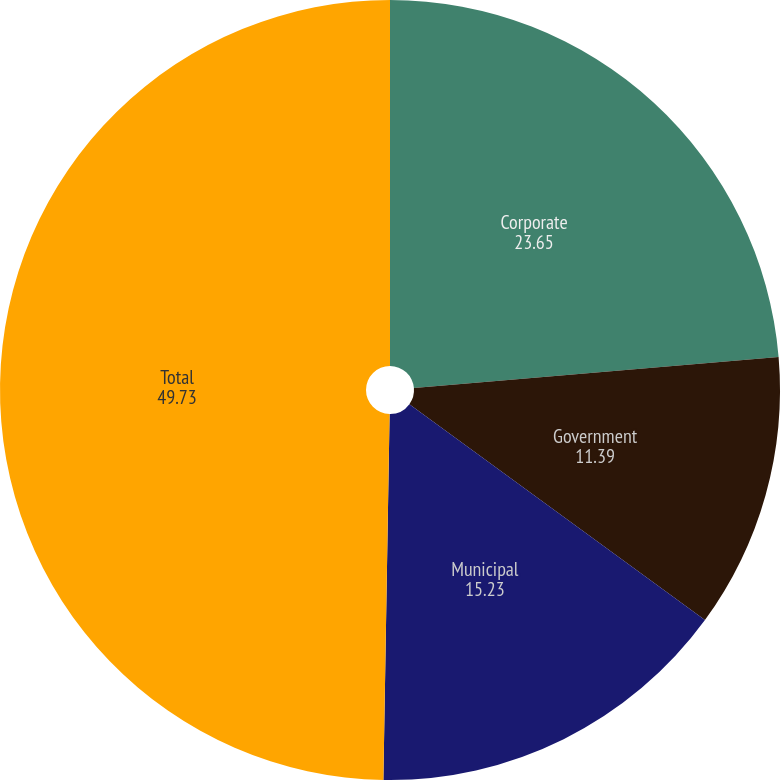Convert chart. <chart><loc_0><loc_0><loc_500><loc_500><pie_chart><fcel>Corporate<fcel>Government<fcel>Municipal<fcel>Total<nl><fcel>23.65%<fcel>11.39%<fcel>15.23%<fcel>49.73%<nl></chart> 